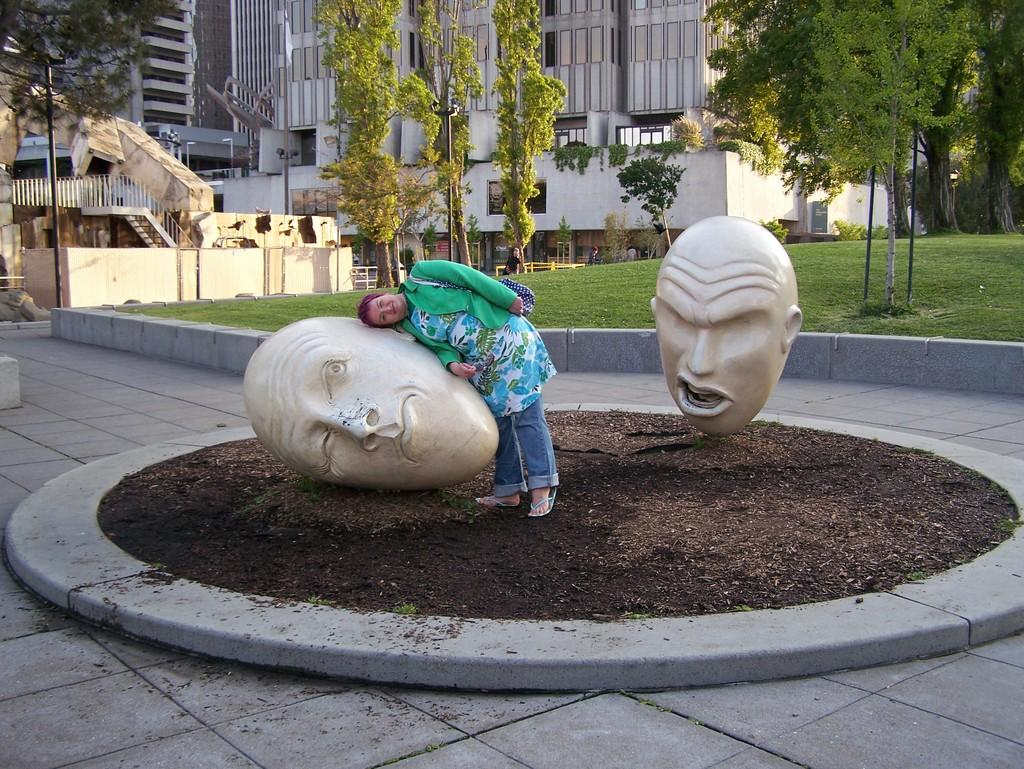Who is present in the image? There is a woman in the image. What can be seen at the bottom of the image? There are statues at the bottom of the image. What type of natural scenery is visible in the background of the image? There are trees in the background of the image. What type of man-made structures can be seen in the background of the image? There are buildings in the background of the image. What type of grip does the dog have on the woman's hand in the image? There is no dog present in the image, so it is not possible to answer that question. 